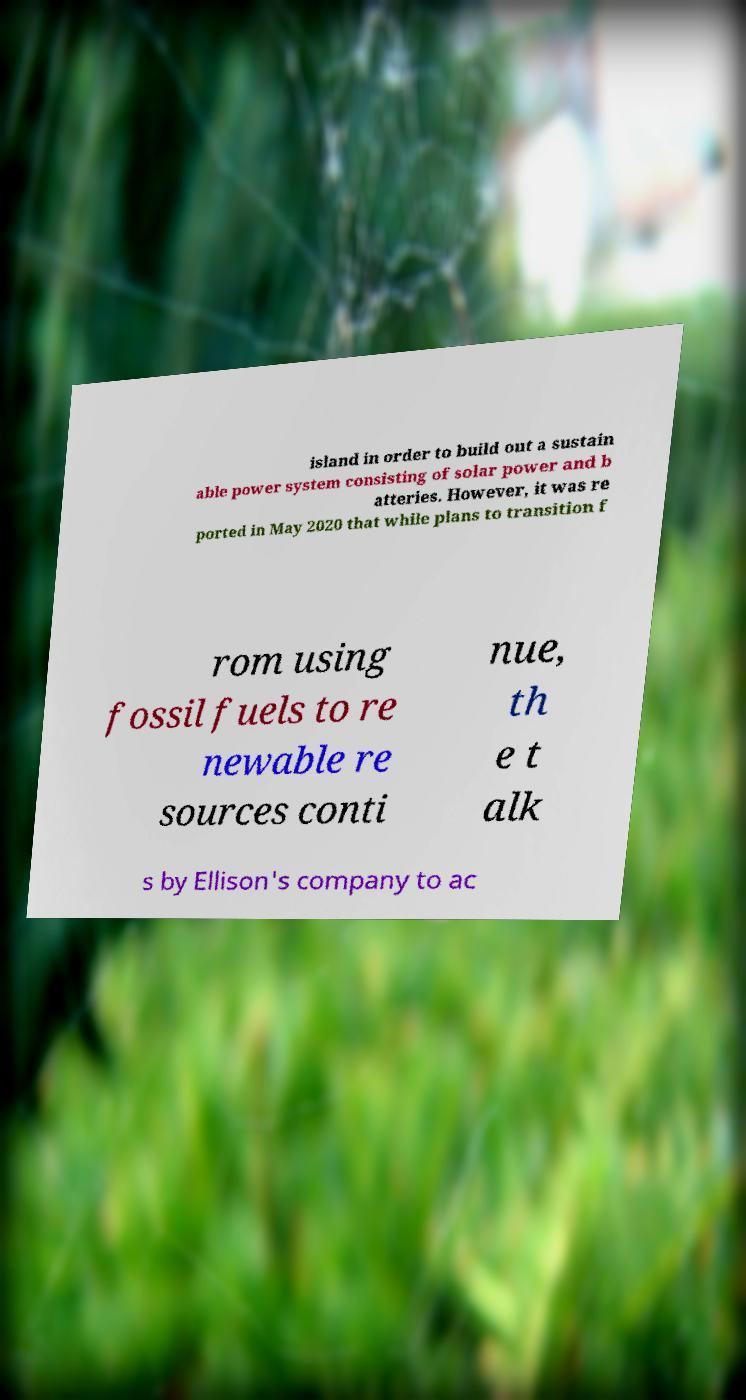Please read and relay the text visible in this image. What does it say? island in order to build out a sustain able power system consisting of solar power and b atteries. However, it was re ported in May 2020 that while plans to transition f rom using fossil fuels to re newable re sources conti nue, th e t alk s by Ellison's company to ac 